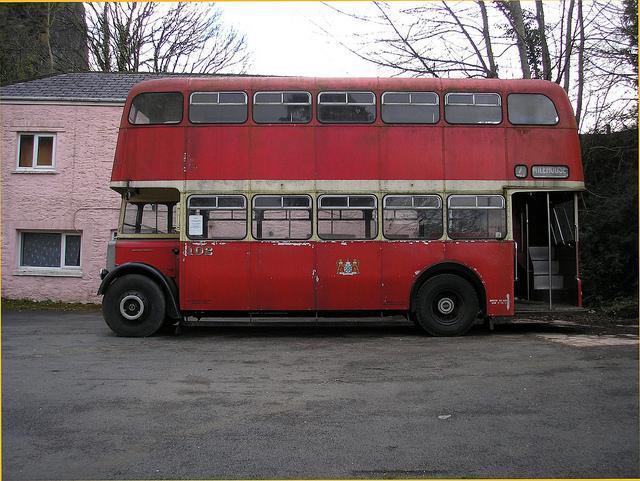How many stories on the bus?
Give a very brief answer. 2. 